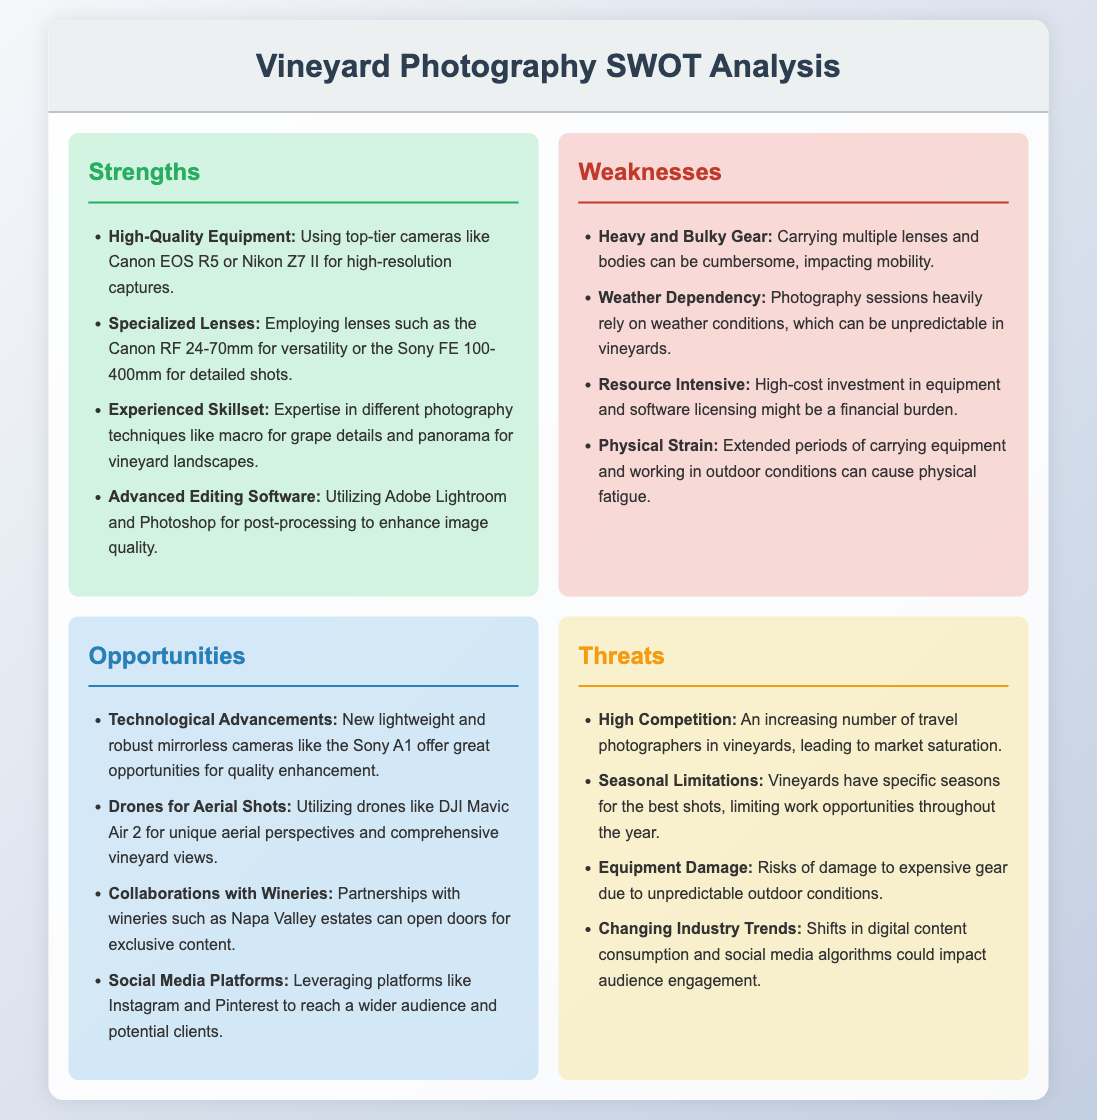What are the strengths listed in the SWOT analysis? Strengths are specific advantages that one can leverage in vineyard photography, detailed in the provided document.
Answer: High-Quality Equipment, Specialized Lenses, Experienced Skillset, Advanced Editing Software What is identified as a weakness affecting mobility? This weakness directly relates to the equipment used in photography, as mentioned in the weaknesses section.
Answer: Heavy and Bulky Gear What type of camera is suggested under opportunities for quality enhancement? The document names a specific model of camera that represents technological advancements in the photography space.
Answer: Sony A1 What does the document suggest utilizing for unique aerial shots? This question relates to the opportunities section, focusing on a modern tool for capturing images from the air.
Answer: Drones How many weaknesses are listed in the SWOT analysis? The total number of weaknesses is highlighted in the document for clarity on challenges faced.
Answer: Four What are the threats related to changing industry trends? This question targets potential challenges that photographers may face, as outlined in the threats section.
Answer: Changing Industry Trends 